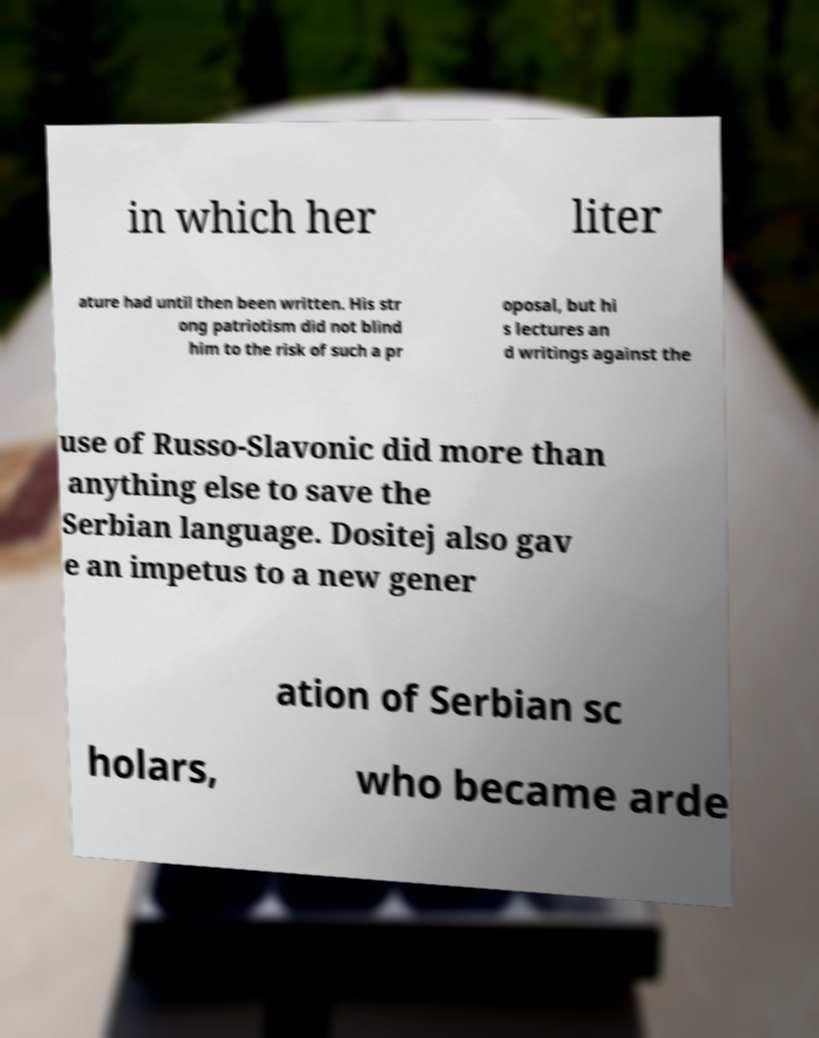Could you extract and type out the text from this image? in which her liter ature had until then been written. His str ong patriotism did not blind him to the risk of such a pr oposal, but hi s lectures an d writings against the use of Russo-Slavonic did more than anything else to save the Serbian language. Dositej also gav e an impetus to a new gener ation of Serbian sc holars, who became arde 